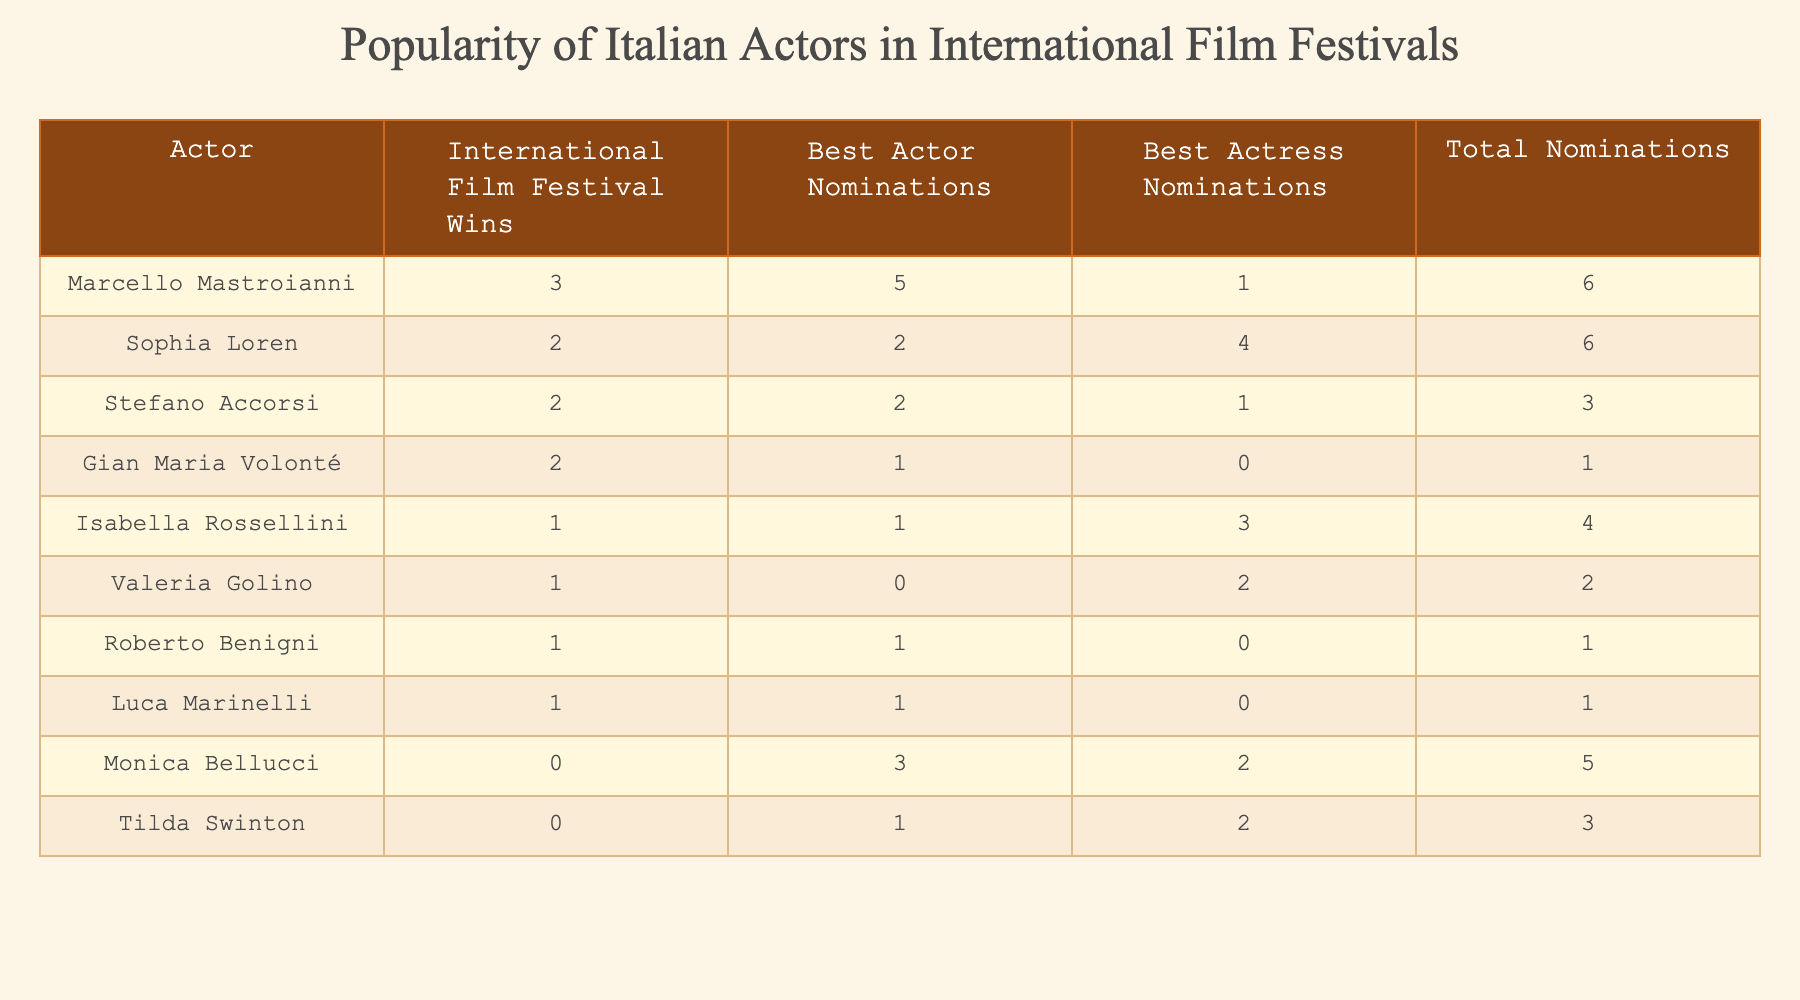What actor has the highest number of International Film Festival Wins? By examining the column labeled "International Film Festival Wins," we can see that Marcello Mastroianni has the highest count at 3.
Answer: Marcello Mastroianni How many Best Actress Nominations does Sophia Loren have? The table shows that Sophia Loren has 4 nominations under the "Best Actress Nominations" column.
Answer: 4 Which actor has more total nominations, Roberto Benigni or Luca Marinelli? Roberto Benigni has a total of 1 nomination (1 Best Actor) while Luca Marinelli has 1 nomination (1 Best Actor), making their total nominations equal.
Answer: Equal What is the total number of Best Actor and Best Actress nominations for Monica Bellucci? Adding her nominations in both categories, 3 (Best Actor) + 2 (Best Actress) equals 5 total nominations.
Answer: 5 Is it true that no actor in the table has won an International Film Festival award and also received Best Actor nominations? Cross-referencing the data, we find that Roberto Benigni won 1 award and has 1 nomination, meaning the statement is false.
Answer: False What is the average number of International Film Festival Wins among the actors listed? Summing the wins (3 + 2 + 1 + 0 + 2 + 2 + 1 + 0 + 1 + 1 = 13) gives us a total of 13 wins across 10 actors. Dividing gives an average of 13/10 = 1.3.
Answer: 1.3 Which actor has the highest combined total of nominations? To find this, we compute total nominations for each actor. Sophia Loren (6), Marcello Mastroianni (6), and others have lower totals. Both Marcello and Sophia tie at 6.
Answer: Marcello Mastroianni and Sophia Loren How many actors received no wins or nominations at all? Evaluating the data, Monica Bellucci and Tilda Swinton have no wins and at least nominations, while all others have some nominations or wins. Thus, there are no actors completely without nominations.
Answer: 0 What is the difference between the highest and lowest number of Best Actor nominations among the actors? The highest is 5 nominations (Marcello Mastroianni) and the lowest is 0 (Monica Bellucci and Tilda Swinton). The difference is 5 - 0 = 5.
Answer: 5 